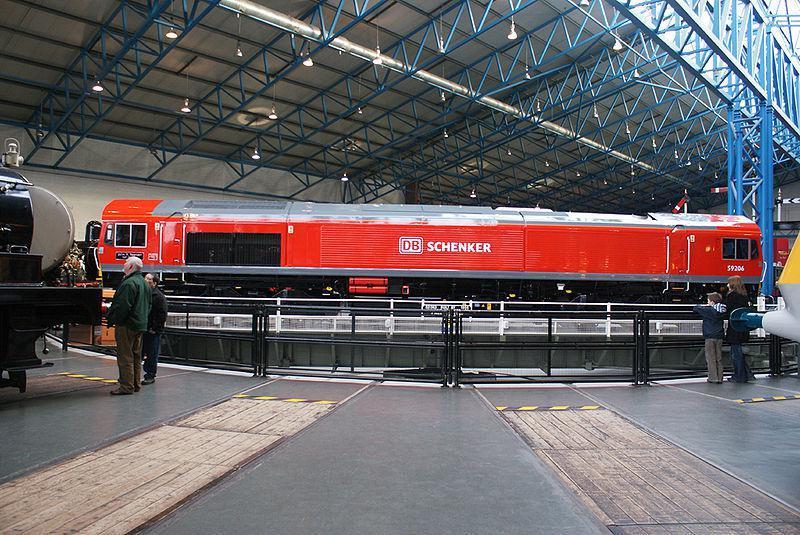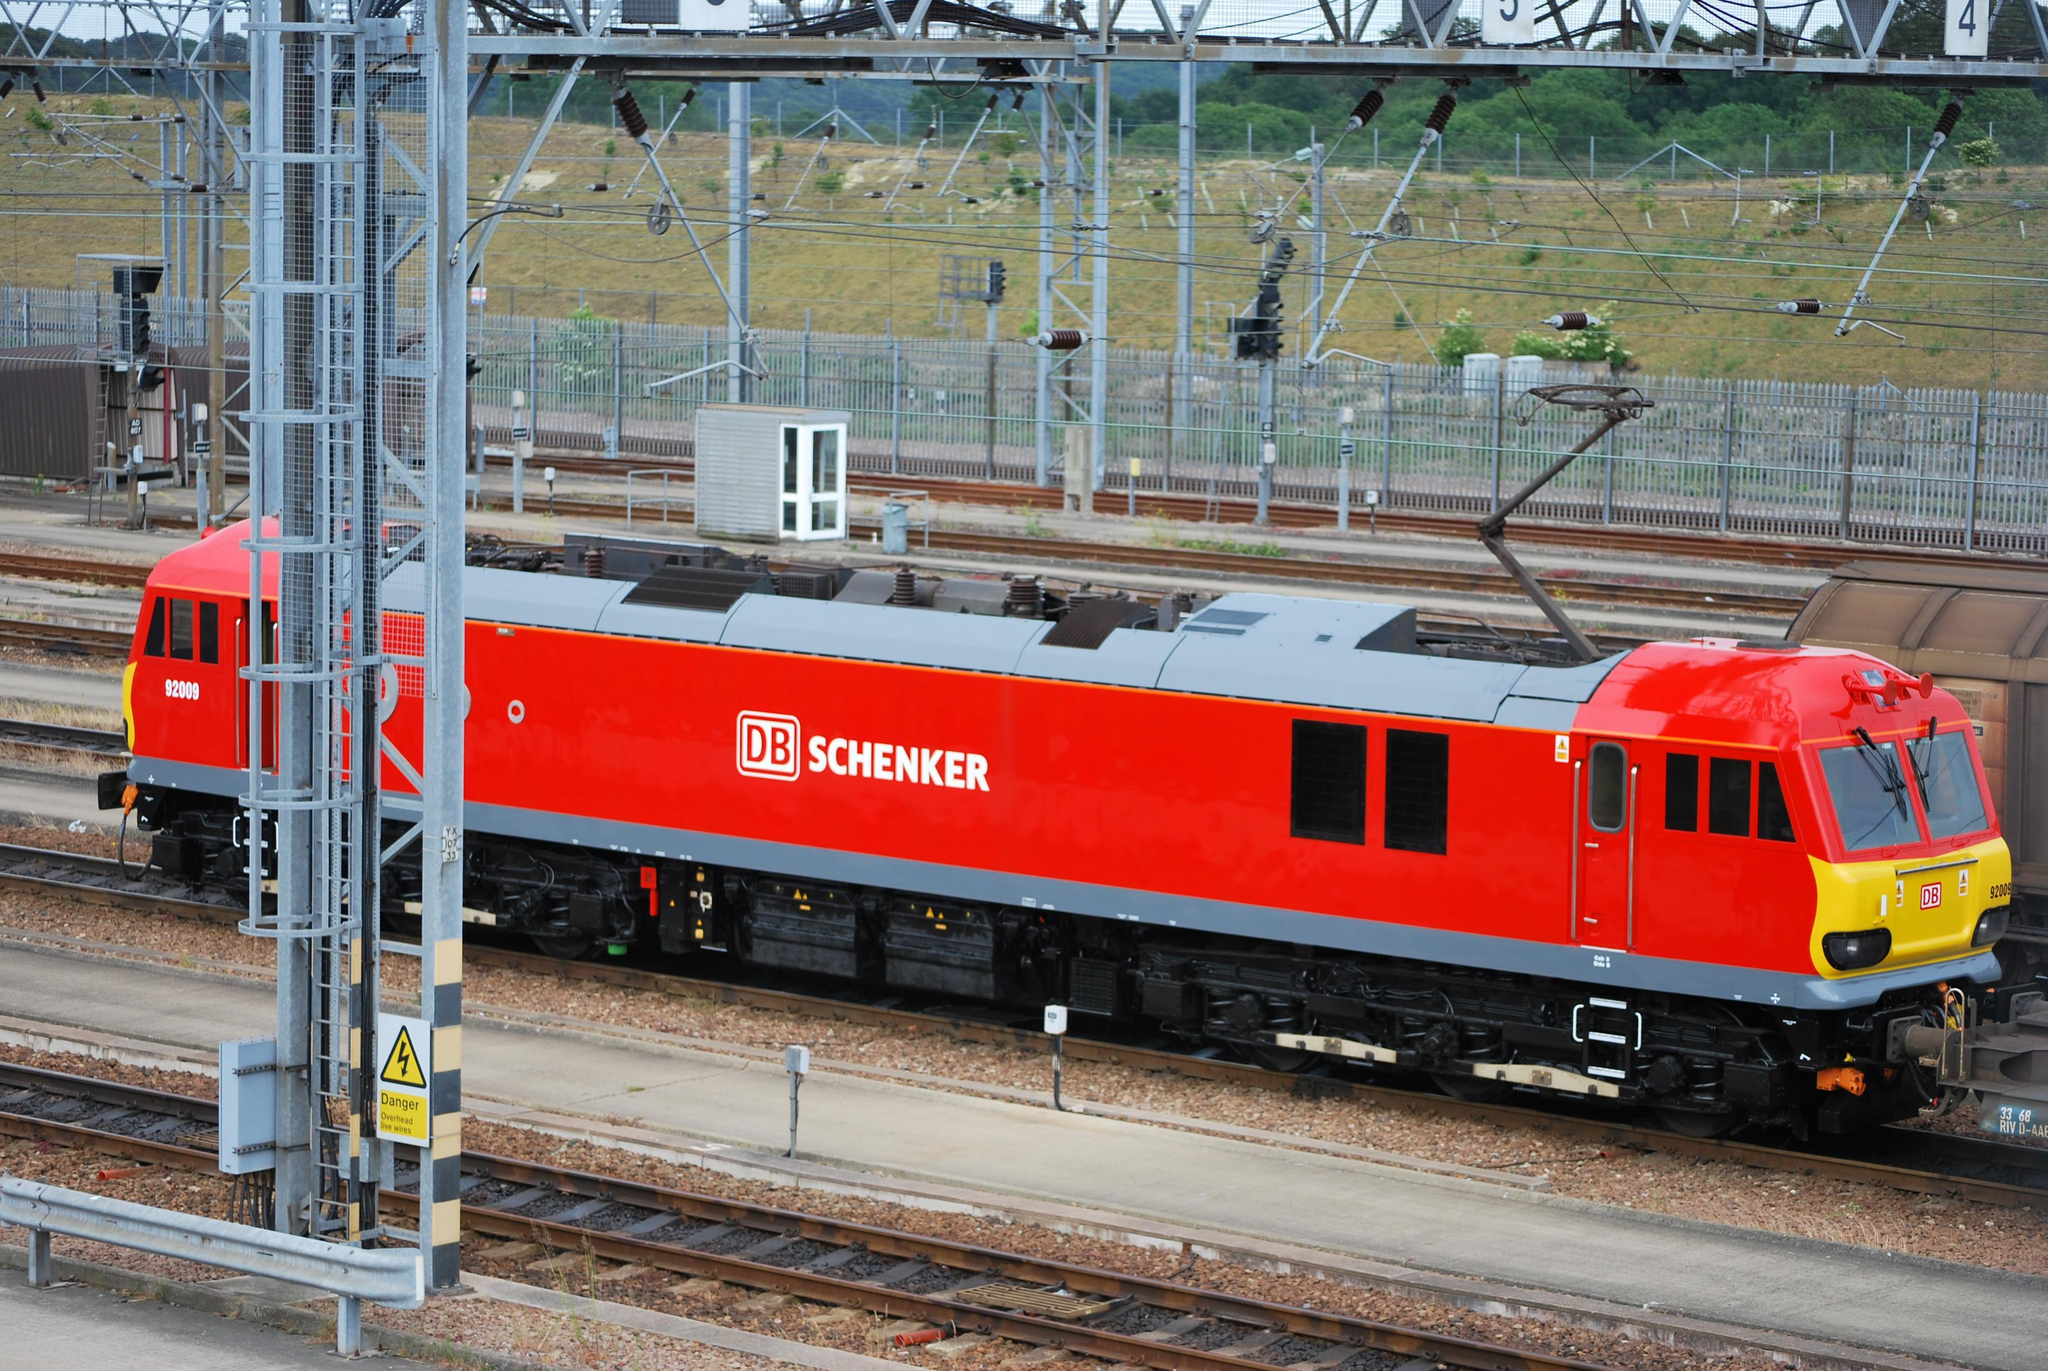The first image is the image on the left, the second image is the image on the right. Examine the images to the left and right. Is the description "People are standing by a railing next to a train in one image." accurate? Answer yes or no. Yes. The first image is the image on the left, the second image is the image on the right. Considering the images on both sides, is "A train locomotive in each image is a distinct style and color, and positioned at a different angle than that of the other image." valid? Answer yes or no. No. 